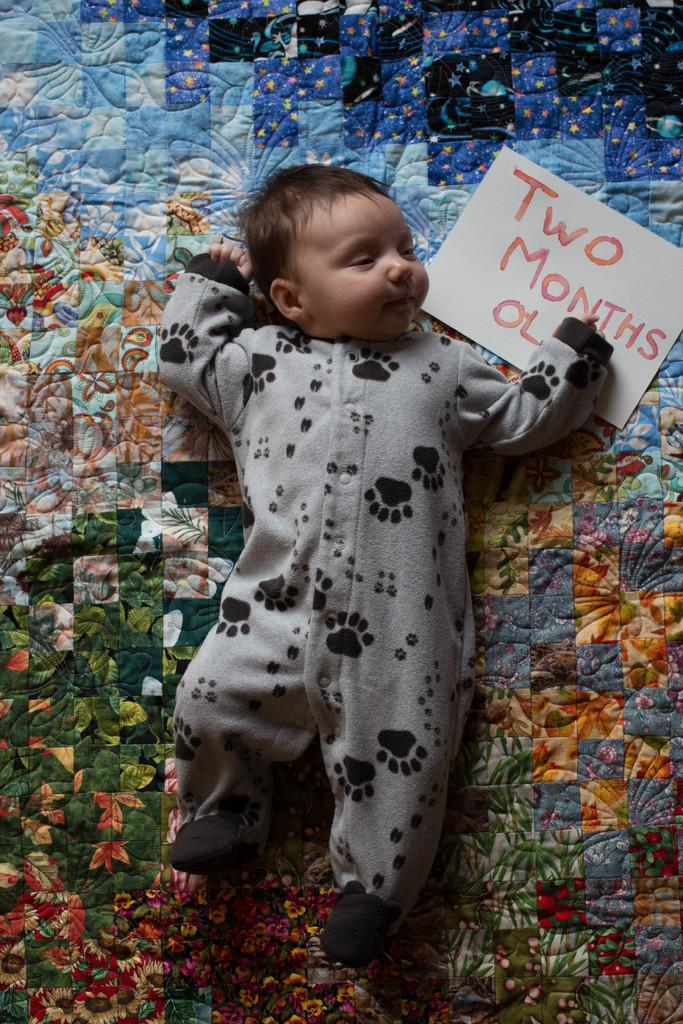What is the main subject of the image? There is a baby in the image. What is the baby doing in the image? The baby is sleeping. What else can be seen in the image besides the baby? There is a paper in the image. Is there any text or writing on the paper? Yes, something is written on the paper. What type of temper does the baby have in the image? There is no indication of the baby's temper in the image, as it is sleeping. What kind of flag is visible in the image? There is no flag present in the image. 